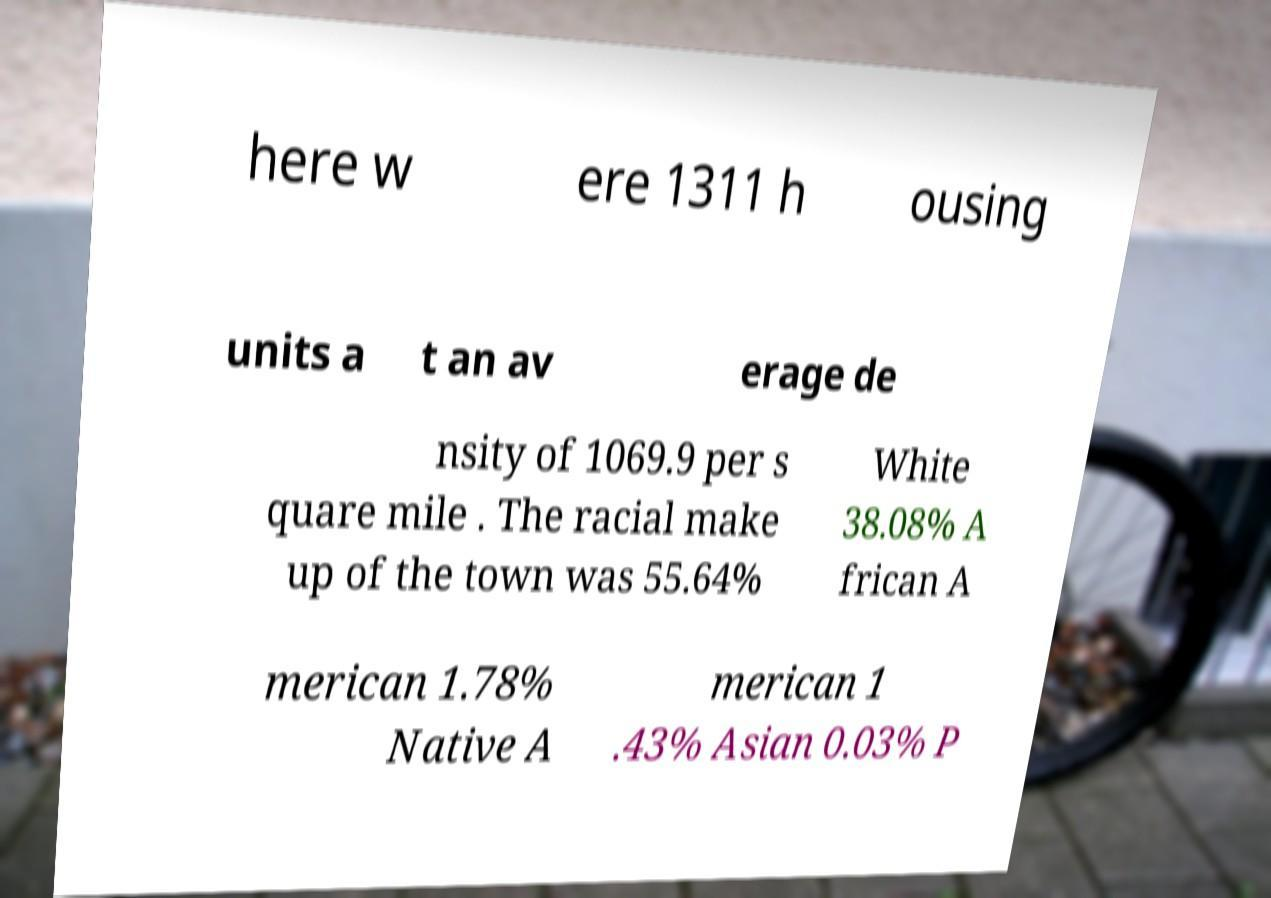There's text embedded in this image that I need extracted. Can you transcribe it verbatim? here w ere 1311 h ousing units a t an av erage de nsity of 1069.9 per s quare mile . The racial make up of the town was 55.64% White 38.08% A frican A merican 1.78% Native A merican 1 .43% Asian 0.03% P 